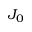Convert formula to latex. <formula><loc_0><loc_0><loc_500><loc_500>J _ { 0 }</formula> 